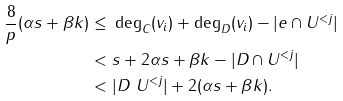<formula> <loc_0><loc_0><loc_500><loc_500>\frac { 8 } p ( \alpha s + \beta k ) \leq & \ \deg _ { C } ( v _ { i } ) + \deg _ { D } ( v _ { i } ) - | e \cap U ^ { < j } | \\ < & \ s + 2 \alpha s + \beta k - | D \cap U ^ { < j } | \\ < & \ | D \ U ^ { < j } | + 2 ( \alpha s + \beta k ) .</formula> 